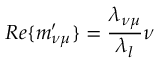<formula> <loc_0><loc_0><loc_500><loc_500>R e \{ m _ { \nu \mu } ^ { \prime } \} = \frac { \lambda _ { \nu \mu } } { \lambda _ { l } } \nu</formula> 